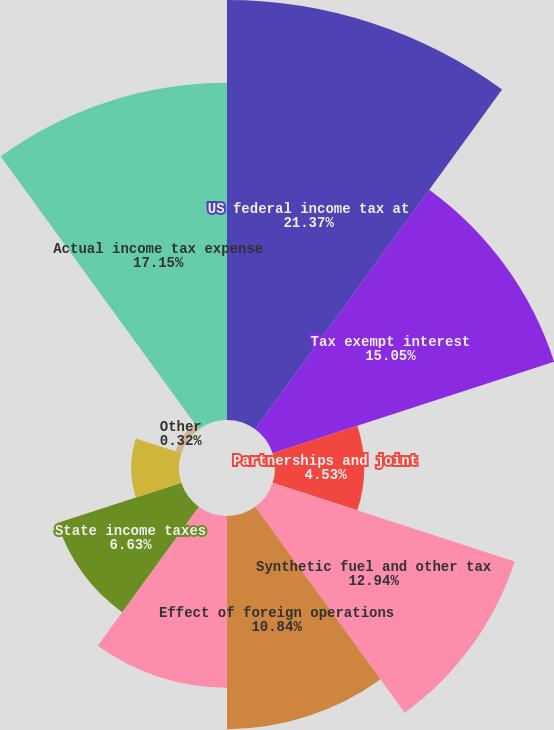Convert chart. <chart><loc_0><loc_0><loc_500><loc_500><pie_chart><fcel>US federal income tax at<fcel>Tax exempt interest<fcel>Partnerships and joint<fcel>Synthetic fuel and other tax<fcel>Effect of foreign operations<fcel>Dividends received deduction<fcel>State income taxes<fcel>Nondeductible compensation<fcel>Other<fcel>Actual income tax expense<nl><fcel>21.36%<fcel>15.05%<fcel>4.53%<fcel>12.94%<fcel>10.84%<fcel>8.74%<fcel>6.63%<fcel>2.43%<fcel>0.32%<fcel>17.15%<nl></chart> 